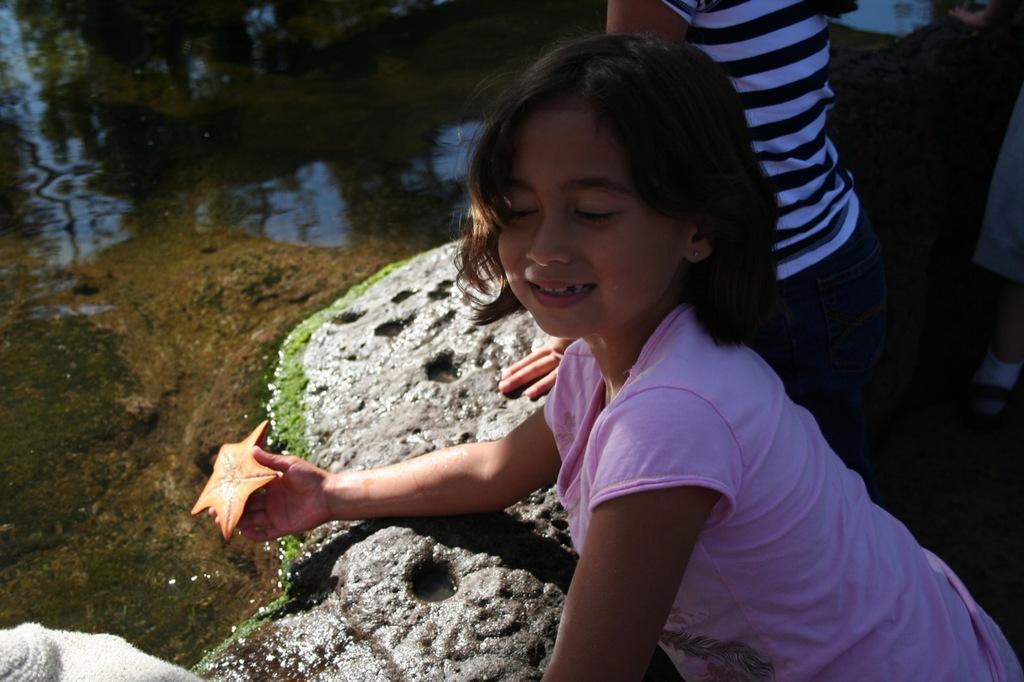Can you describe this image briefly? In the center of the image we can see a girl holding a stone in her hand. In the background there are people. On the left there is water and rock. 